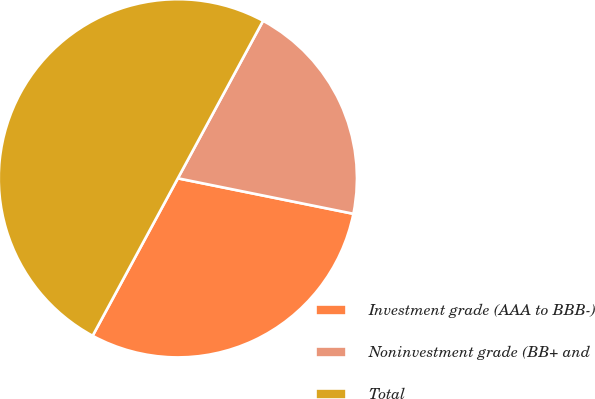<chart> <loc_0><loc_0><loc_500><loc_500><pie_chart><fcel>Investment grade (AAA to BBB-)<fcel>Noninvestment grade (BB+ and<fcel>Total<nl><fcel>29.72%<fcel>20.28%<fcel>50.0%<nl></chart> 